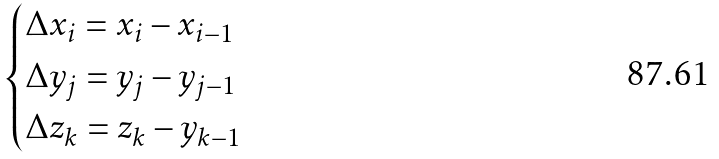<formula> <loc_0><loc_0><loc_500><loc_500>\begin{cases} \Delta x _ { i } = x _ { i } - x _ { i - 1 } \\ \Delta y _ { j } = y _ { j } - y _ { j - 1 } \\ \Delta z _ { k } = z _ { k } - y _ { k - 1 } \end{cases}</formula> 